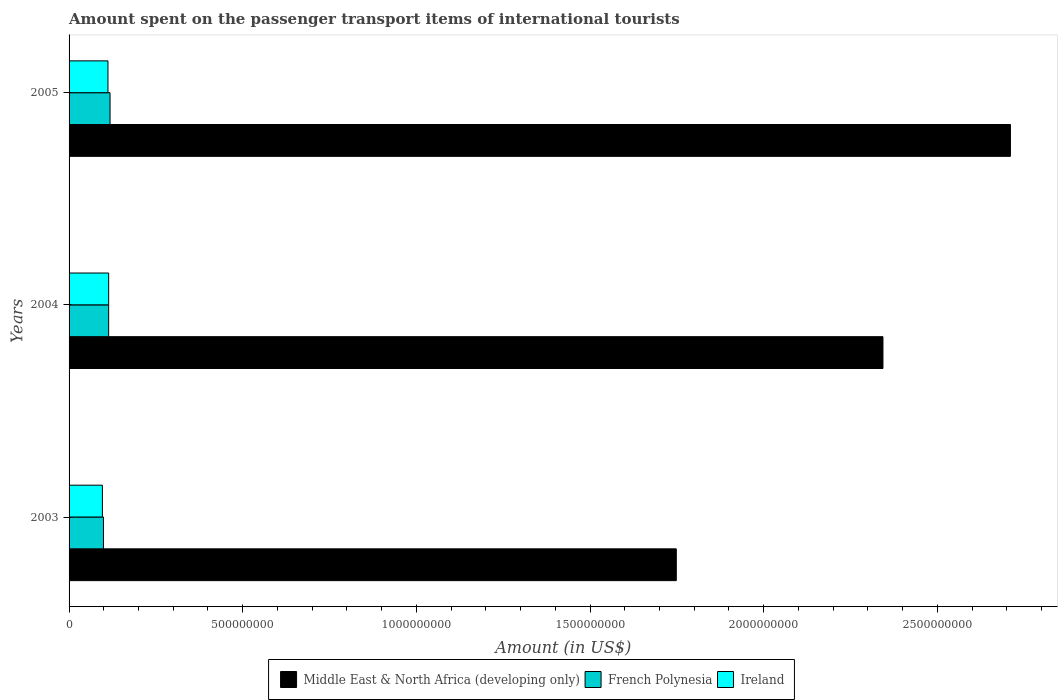How many different coloured bars are there?
Give a very brief answer. 3. How many bars are there on the 1st tick from the bottom?
Your response must be concise. 3. What is the amount spent on the passenger transport items of international tourists in Ireland in 2004?
Make the answer very short. 1.14e+08. Across all years, what is the maximum amount spent on the passenger transport items of international tourists in French Polynesia?
Your response must be concise. 1.18e+08. Across all years, what is the minimum amount spent on the passenger transport items of international tourists in Middle East & North Africa (developing only)?
Ensure brevity in your answer.  1.75e+09. In which year was the amount spent on the passenger transport items of international tourists in French Polynesia minimum?
Offer a very short reply. 2003. What is the total amount spent on the passenger transport items of international tourists in French Polynesia in the graph?
Provide a succinct answer. 3.31e+08. What is the difference between the amount spent on the passenger transport items of international tourists in Middle East & North Africa (developing only) in 2003 and that in 2004?
Make the answer very short. -5.95e+08. What is the difference between the amount spent on the passenger transport items of international tourists in Middle East & North Africa (developing only) in 2005 and the amount spent on the passenger transport items of international tourists in Ireland in 2003?
Provide a succinct answer. 2.61e+09. What is the average amount spent on the passenger transport items of international tourists in Ireland per year?
Give a very brief answer. 1.07e+08. In the year 2003, what is the difference between the amount spent on the passenger transport items of international tourists in Middle East & North Africa (developing only) and amount spent on the passenger transport items of international tourists in Ireland?
Keep it short and to the point. 1.65e+09. What is the ratio of the amount spent on the passenger transport items of international tourists in French Polynesia in 2003 to that in 2005?
Give a very brief answer. 0.84. Is the amount spent on the passenger transport items of international tourists in Ireland in 2004 less than that in 2005?
Make the answer very short. No. Is the difference between the amount spent on the passenger transport items of international tourists in Middle East & North Africa (developing only) in 2003 and 2005 greater than the difference between the amount spent on the passenger transport items of international tourists in Ireland in 2003 and 2005?
Keep it short and to the point. No. What is the difference between the highest and the second highest amount spent on the passenger transport items of international tourists in Ireland?
Offer a very short reply. 2.00e+06. What is the difference between the highest and the lowest amount spent on the passenger transport items of international tourists in French Polynesia?
Give a very brief answer. 1.90e+07. In how many years, is the amount spent on the passenger transport items of international tourists in Ireland greater than the average amount spent on the passenger transport items of international tourists in Ireland taken over all years?
Offer a very short reply. 2. Is the sum of the amount spent on the passenger transport items of international tourists in French Polynesia in 2004 and 2005 greater than the maximum amount spent on the passenger transport items of international tourists in Ireland across all years?
Make the answer very short. Yes. What does the 3rd bar from the top in 2003 represents?
Keep it short and to the point. Middle East & North Africa (developing only). What does the 2nd bar from the bottom in 2005 represents?
Give a very brief answer. French Polynesia. Is it the case that in every year, the sum of the amount spent on the passenger transport items of international tourists in French Polynesia and amount spent on the passenger transport items of international tourists in Middle East & North Africa (developing only) is greater than the amount spent on the passenger transport items of international tourists in Ireland?
Provide a succinct answer. Yes. Are all the bars in the graph horizontal?
Give a very brief answer. Yes. What is the difference between two consecutive major ticks on the X-axis?
Offer a terse response. 5.00e+08. Are the values on the major ticks of X-axis written in scientific E-notation?
Offer a very short reply. No. Does the graph contain grids?
Your answer should be very brief. No. Where does the legend appear in the graph?
Your response must be concise. Bottom center. How many legend labels are there?
Keep it short and to the point. 3. What is the title of the graph?
Your response must be concise. Amount spent on the passenger transport items of international tourists. What is the label or title of the Y-axis?
Your answer should be very brief. Years. What is the Amount (in US$) of Middle East & North Africa (developing only) in 2003?
Offer a very short reply. 1.75e+09. What is the Amount (in US$) in French Polynesia in 2003?
Offer a very short reply. 9.90e+07. What is the Amount (in US$) of Ireland in 2003?
Your response must be concise. 9.60e+07. What is the Amount (in US$) of Middle East & North Africa (developing only) in 2004?
Make the answer very short. 2.34e+09. What is the Amount (in US$) in French Polynesia in 2004?
Offer a terse response. 1.14e+08. What is the Amount (in US$) in Ireland in 2004?
Make the answer very short. 1.14e+08. What is the Amount (in US$) of Middle East & North Africa (developing only) in 2005?
Provide a short and direct response. 2.71e+09. What is the Amount (in US$) in French Polynesia in 2005?
Provide a succinct answer. 1.18e+08. What is the Amount (in US$) in Ireland in 2005?
Give a very brief answer. 1.12e+08. Across all years, what is the maximum Amount (in US$) in Middle East & North Africa (developing only)?
Provide a succinct answer. 2.71e+09. Across all years, what is the maximum Amount (in US$) in French Polynesia?
Your answer should be compact. 1.18e+08. Across all years, what is the maximum Amount (in US$) in Ireland?
Make the answer very short. 1.14e+08. Across all years, what is the minimum Amount (in US$) of Middle East & North Africa (developing only)?
Your response must be concise. 1.75e+09. Across all years, what is the minimum Amount (in US$) in French Polynesia?
Keep it short and to the point. 9.90e+07. Across all years, what is the minimum Amount (in US$) in Ireland?
Your answer should be very brief. 9.60e+07. What is the total Amount (in US$) in Middle East & North Africa (developing only) in the graph?
Give a very brief answer. 6.80e+09. What is the total Amount (in US$) in French Polynesia in the graph?
Offer a very short reply. 3.31e+08. What is the total Amount (in US$) of Ireland in the graph?
Your answer should be compact. 3.22e+08. What is the difference between the Amount (in US$) in Middle East & North Africa (developing only) in 2003 and that in 2004?
Ensure brevity in your answer.  -5.95e+08. What is the difference between the Amount (in US$) in French Polynesia in 2003 and that in 2004?
Make the answer very short. -1.50e+07. What is the difference between the Amount (in US$) of Ireland in 2003 and that in 2004?
Your answer should be very brief. -1.80e+07. What is the difference between the Amount (in US$) in Middle East & North Africa (developing only) in 2003 and that in 2005?
Ensure brevity in your answer.  -9.62e+08. What is the difference between the Amount (in US$) of French Polynesia in 2003 and that in 2005?
Provide a short and direct response. -1.90e+07. What is the difference between the Amount (in US$) of Ireland in 2003 and that in 2005?
Provide a succinct answer. -1.60e+07. What is the difference between the Amount (in US$) in Middle East & North Africa (developing only) in 2004 and that in 2005?
Provide a short and direct response. -3.67e+08. What is the difference between the Amount (in US$) of French Polynesia in 2004 and that in 2005?
Provide a short and direct response. -4.00e+06. What is the difference between the Amount (in US$) in Middle East & North Africa (developing only) in 2003 and the Amount (in US$) in French Polynesia in 2004?
Give a very brief answer. 1.63e+09. What is the difference between the Amount (in US$) of Middle East & North Africa (developing only) in 2003 and the Amount (in US$) of Ireland in 2004?
Offer a very short reply. 1.63e+09. What is the difference between the Amount (in US$) of French Polynesia in 2003 and the Amount (in US$) of Ireland in 2004?
Provide a short and direct response. -1.50e+07. What is the difference between the Amount (in US$) in Middle East & North Africa (developing only) in 2003 and the Amount (in US$) in French Polynesia in 2005?
Keep it short and to the point. 1.63e+09. What is the difference between the Amount (in US$) of Middle East & North Africa (developing only) in 2003 and the Amount (in US$) of Ireland in 2005?
Ensure brevity in your answer.  1.64e+09. What is the difference between the Amount (in US$) in French Polynesia in 2003 and the Amount (in US$) in Ireland in 2005?
Give a very brief answer. -1.30e+07. What is the difference between the Amount (in US$) of Middle East & North Africa (developing only) in 2004 and the Amount (in US$) of French Polynesia in 2005?
Give a very brief answer. 2.23e+09. What is the difference between the Amount (in US$) of Middle East & North Africa (developing only) in 2004 and the Amount (in US$) of Ireland in 2005?
Your answer should be very brief. 2.23e+09. What is the difference between the Amount (in US$) of French Polynesia in 2004 and the Amount (in US$) of Ireland in 2005?
Your response must be concise. 2.00e+06. What is the average Amount (in US$) of Middle East & North Africa (developing only) per year?
Make the answer very short. 2.27e+09. What is the average Amount (in US$) of French Polynesia per year?
Your answer should be very brief. 1.10e+08. What is the average Amount (in US$) of Ireland per year?
Keep it short and to the point. 1.07e+08. In the year 2003, what is the difference between the Amount (in US$) of Middle East & North Africa (developing only) and Amount (in US$) of French Polynesia?
Keep it short and to the point. 1.65e+09. In the year 2003, what is the difference between the Amount (in US$) of Middle East & North Africa (developing only) and Amount (in US$) of Ireland?
Provide a short and direct response. 1.65e+09. In the year 2004, what is the difference between the Amount (in US$) of Middle East & North Africa (developing only) and Amount (in US$) of French Polynesia?
Give a very brief answer. 2.23e+09. In the year 2004, what is the difference between the Amount (in US$) in Middle East & North Africa (developing only) and Amount (in US$) in Ireland?
Your response must be concise. 2.23e+09. In the year 2004, what is the difference between the Amount (in US$) of French Polynesia and Amount (in US$) of Ireland?
Offer a very short reply. 0. In the year 2005, what is the difference between the Amount (in US$) of Middle East & North Africa (developing only) and Amount (in US$) of French Polynesia?
Your answer should be compact. 2.59e+09. In the year 2005, what is the difference between the Amount (in US$) in Middle East & North Africa (developing only) and Amount (in US$) in Ireland?
Ensure brevity in your answer.  2.60e+09. In the year 2005, what is the difference between the Amount (in US$) of French Polynesia and Amount (in US$) of Ireland?
Your answer should be very brief. 6.00e+06. What is the ratio of the Amount (in US$) of Middle East & North Africa (developing only) in 2003 to that in 2004?
Offer a terse response. 0.75. What is the ratio of the Amount (in US$) of French Polynesia in 2003 to that in 2004?
Provide a short and direct response. 0.87. What is the ratio of the Amount (in US$) of Ireland in 2003 to that in 2004?
Your answer should be very brief. 0.84. What is the ratio of the Amount (in US$) of Middle East & North Africa (developing only) in 2003 to that in 2005?
Ensure brevity in your answer.  0.65. What is the ratio of the Amount (in US$) of French Polynesia in 2003 to that in 2005?
Give a very brief answer. 0.84. What is the ratio of the Amount (in US$) in Ireland in 2003 to that in 2005?
Offer a very short reply. 0.86. What is the ratio of the Amount (in US$) in Middle East & North Africa (developing only) in 2004 to that in 2005?
Ensure brevity in your answer.  0.86. What is the ratio of the Amount (in US$) in French Polynesia in 2004 to that in 2005?
Offer a very short reply. 0.97. What is the ratio of the Amount (in US$) in Ireland in 2004 to that in 2005?
Offer a very short reply. 1.02. What is the difference between the highest and the second highest Amount (in US$) in Middle East & North Africa (developing only)?
Offer a terse response. 3.67e+08. What is the difference between the highest and the second highest Amount (in US$) of Ireland?
Your answer should be very brief. 2.00e+06. What is the difference between the highest and the lowest Amount (in US$) in Middle East & North Africa (developing only)?
Provide a short and direct response. 9.62e+08. What is the difference between the highest and the lowest Amount (in US$) of French Polynesia?
Your response must be concise. 1.90e+07. What is the difference between the highest and the lowest Amount (in US$) of Ireland?
Your answer should be very brief. 1.80e+07. 